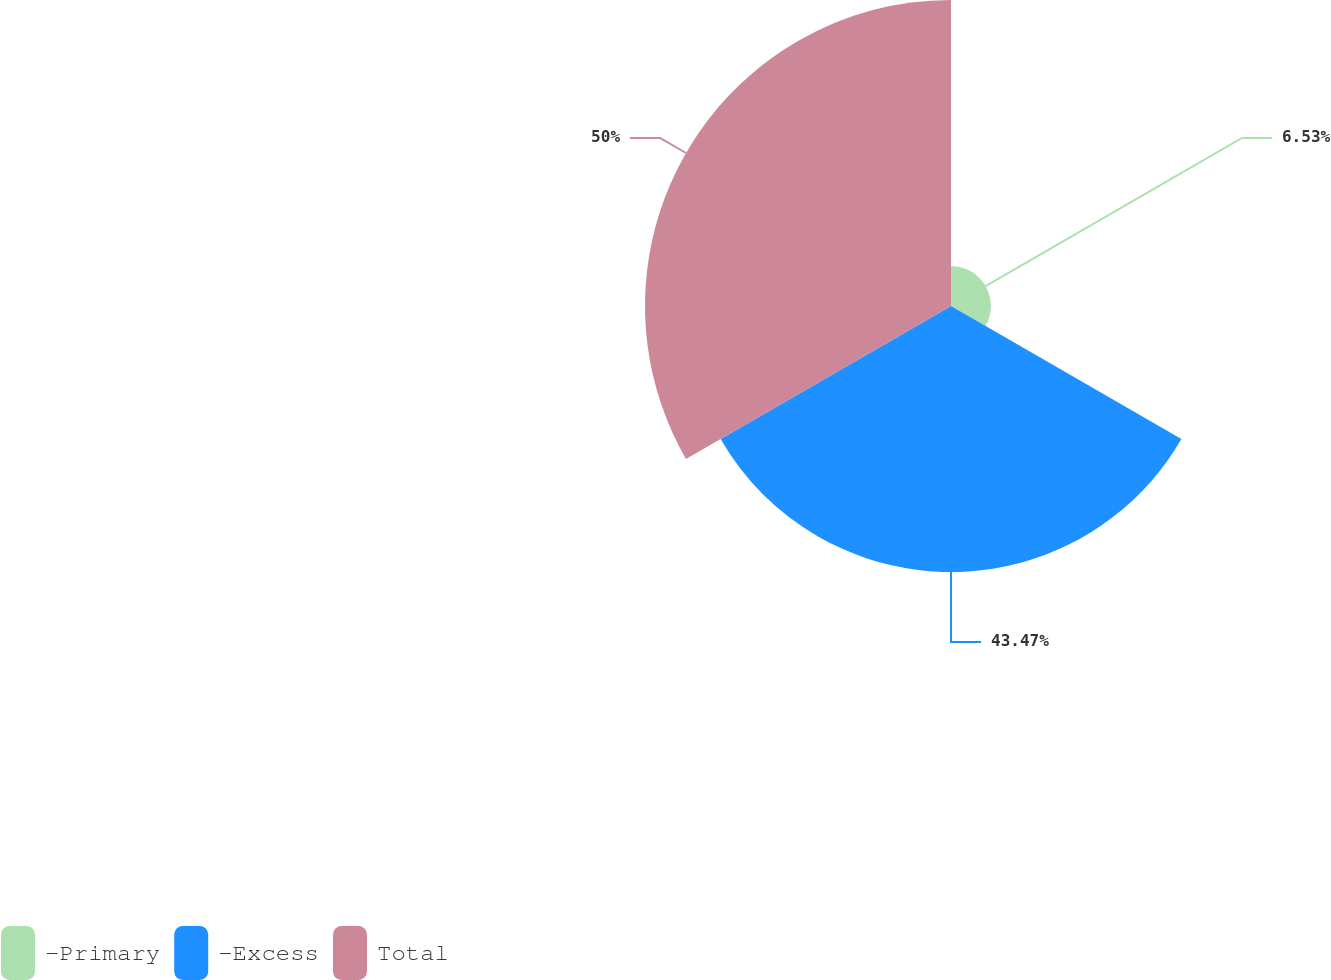Convert chart to OTSL. <chart><loc_0><loc_0><loc_500><loc_500><pie_chart><fcel>-Primary<fcel>-Excess<fcel>Total<nl><fcel>6.53%<fcel>43.47%<fcel>50.0%<nl></chart> 